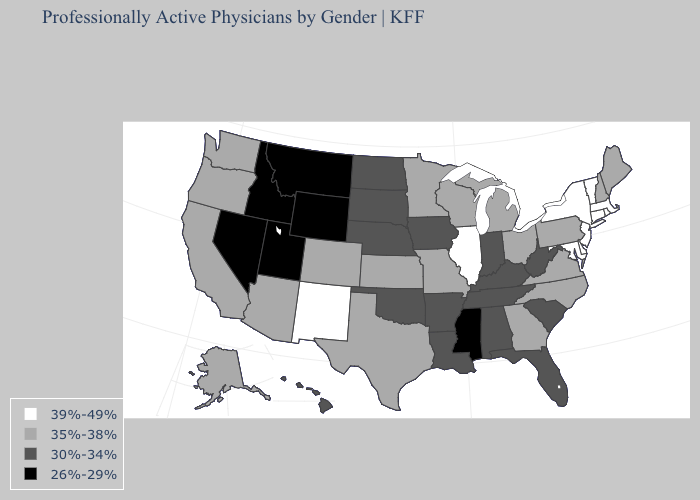What is the value of North Dakota?
Short answer required. 30%-34%. Name the states that have a value in the range 26%-29%?
Short answer required. Idaho, Mississippi, Montana, Nevada, Utah, Wyoming. Does Indiana have a higher value than Arkansas?
Write a very short answer. No. Does New Mexico have the highest value in the West?
Write a very short answer. Yes. What is the value of Maine?
Write a very short answer. 35%-38%. Name the states that have a value in the range 26%-29%?
Keep it brief. Idaho, Mississippi, Montana, Nevada, Utah, Wyoming. What is the highest value in the USA?
Answer briefly. 39%-49%. Does South Dakota have the highest value in the USA?
Give a very brief answer. No. Name the states that have a value in the range 35%-38%?
Keep it brief. Alaska, Arizona, California, Colorado, Georgia, Kansas, Maine, Michigan, Minnesota, Missouri, New Hampshire, North Carolina, Ohio, Oregon, Pennsylvania, Texas, Virginia, Washington, Wisconsin. What is the lowest value in the Northeast?
Write a very short answer. 35%-38%. What is the value of Nevada?
Give a very brief answer. 26%-29%. What is the value of New Mexico?
Answer briefly. 39%-49%. Name the states that have a value in the range 35%-38%?
Short answer required. Alaska, Arizona, California, Colorado, Georgia, Kansas, Maine, Michigan, Minnesota, Missouri, New Hampshire, North Carolina, Ohio, Oregon, Pennsylvania, Texas, Virginia, Washington, Wisconsin. Among the states that border New Jersey , which have the lowest value?
Be succinct. Pennsylvania. 